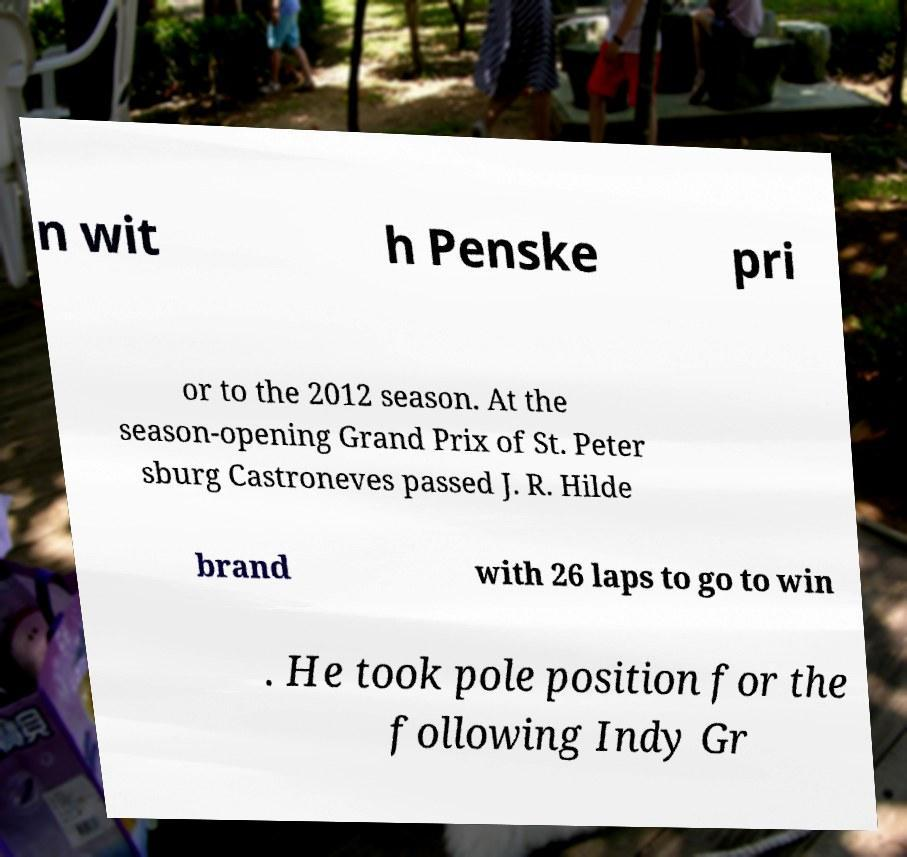I need the written content from this picture converted into text. Can you do that? n wit h Penske pri or to the 2012 season. At the season-opening Grand Prix of St. Peter sburg Castroneves passed J. R. Hilde brand with 26 laps to go to win . He took pole position for the following Indy Gr 